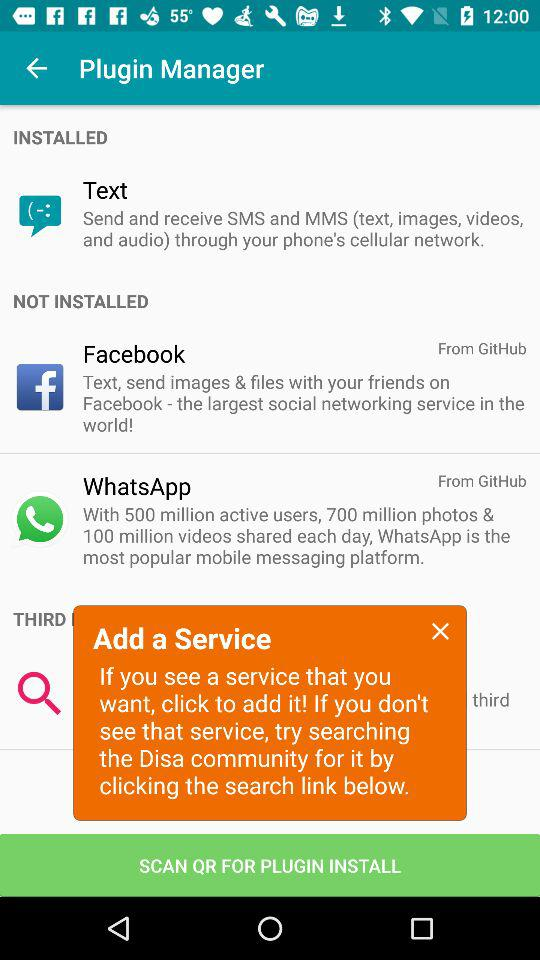How many active "WhatsApp" users are there? There are 500 million active "WhatsApp" users. 